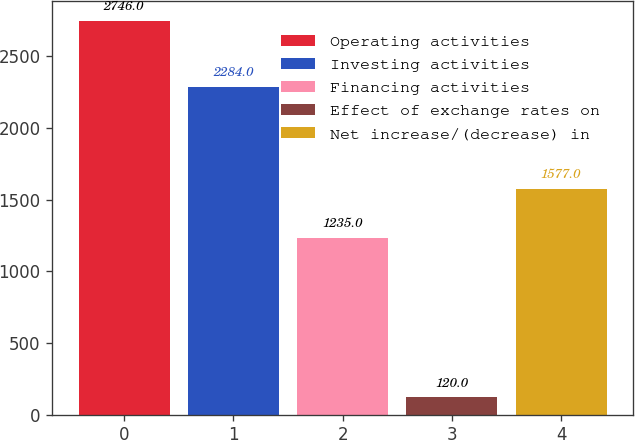Convert chart. <chart><loc_0><loc_0><loc_500><loc_500><bar_chart><fcel>Operating activities<fcel>Investing activities<fcel>Financing activities<fcel>Effect of exchange rates on<fcel>Net increase/(decrease) in<nl><fcel>2746<fcel>2284<fcel>1235<fcel>120<fcel>1577<nl></chart> 